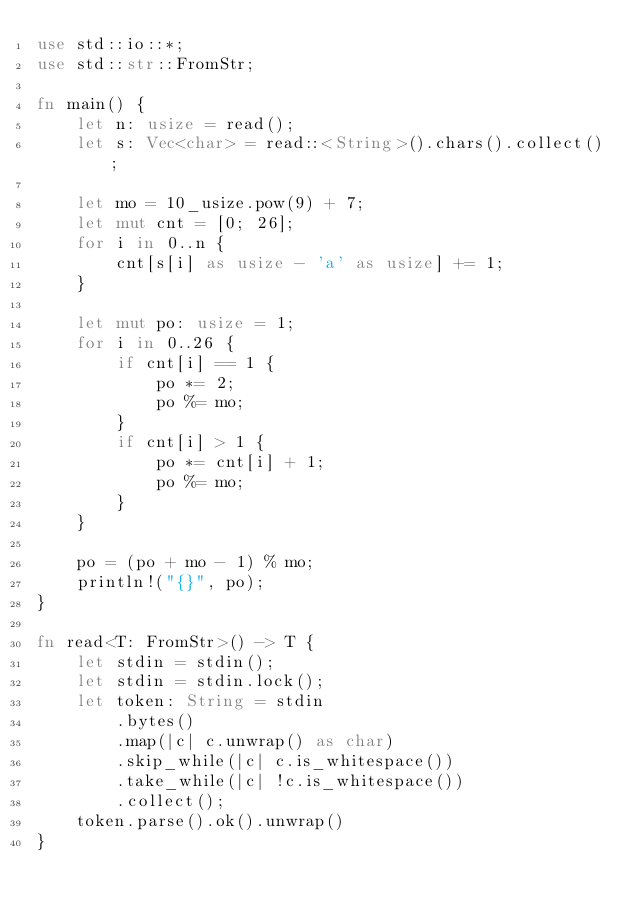<code> <loc_0><loc_0><loc_500><loc_500><_Rust_>use std::io::*;
use std::str::FromStr;

fn main() {
    let n: usize = read();
    let s: Vec<char> = read::<String>().chars().collect();
    
    let mo = 10_usize.pow(9) + 7;
    let mut cnt = [0; 26];
    for i in 0..n {
        cnt[s[i] as usize - 'a' as usize] += 1;
    }

    let mut po: usize = 1;
    for i in 0..26 {
        if cnt[i] == 1 {
            po *= 2;
            po %= mo;
        }
        if cnt[i] > 1 {
            po *= cnt[i] + 1;
            po %= mo;
        }
    }

    po = (po + mo - 1) % mo;
    println!("{}", po);
}

fn read<T: FromStr>() -> T {
    let stdin = stdin();
    let stdin = stdin.lock();
    let token: String = stdin
        .bytes()
        .map(|c| c.unwrap() as char)
        .skip_while(|c| c.is_whitespace())
        .take_while(|c| !c.is_whitespace())
        .collect();
    token.parse().ok().unwrap()
}</code> 